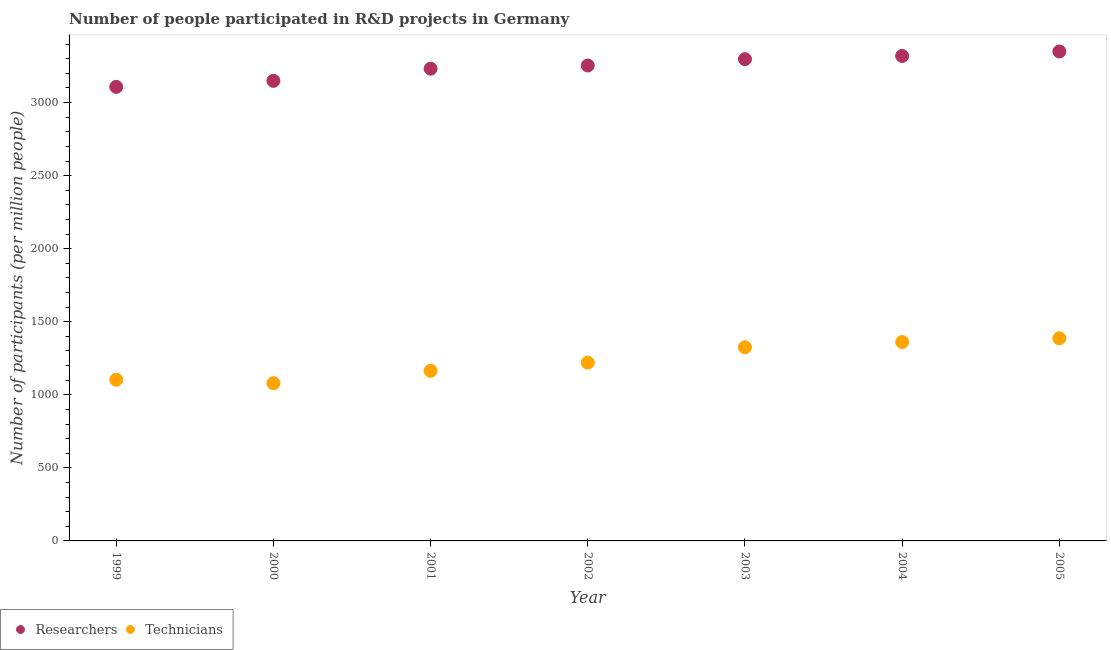Is the number of dotlines equal to the number of legend labels?
Keep it short and to the point. Yes. What is the number of researchers in 1999?
Make the answer very short. 3107.28. Across all years, what is the maximum number of researchers?
Give a very brief answer. 3349.65. Across all years, what is the minimum number of researchers?
Your answer should be very brief. 3107.28. In which year was the number of researchers minimum?
Keep it short and to the point. 1999. What is the total number of researchers in the graph?
Keep it short and to the point. 2.27e+04. What is the difference between the number of technicians in 2000 and that in 2001?
Your response must be concise. -84.8. What is the difference between the number of researchers in 2001 and the number of technicians in 2002?
Give a very brief answer. 2011.3. What is the average number of technicians per year?
Keep it short and to the point. 1234.21. In the year 2003, what is the difference between the number of technicians and number of researchers?
Offer a very short reply. -1971.87. What is the ratio of the number of researchers in 2002 to that in 2005?
Provide a succinct answer. 0.97. Is the number of technicians in 1999 less than that in 2000?
Your response must be concise. No. What is the difference between the highest and the second highest number of researchers?
Offer a terse response. 30.78. What is the difference between the highest and the lowest number of researchers?
Provide a succinct answer. 242.36. In how many years, is the number of researchers greater than the average number of researchers taken over all years?
Provide a short and direct response. 4. Does the number of technicians monotonically increase over the years?
Keep it short and to the point. No. Is the number of researchers strictly greater than the number of technicians over the years?
Keep it short and to the point. Yes. How many dotlines are there?
Provide a succinct answer. 2. How many years are there in the graph?
Your response must be concise. 7. Are the values on the major ticks of Y-axis written in scientific E-notation?
Offer a terse response. No. Does the graph contain any zero values?
Your answer should be very brief. No. Does the graph contain grids?
Offer a very short reply. No. How many legend labels are there?
Provide a short and direct response. 2. How are the legend labels stacked?
Keep it short and to the point. Horizontal. What is the title of the graph?
Provide a succinct answer. Number of people participated in R&D projects in Germany. Does "Researchers" appear as one of the legend labels in the graph?
Provide a short and direct response. Yes. What is the label or title of the X-axis?
Provide a succinct answer. Year. What is the label or title of the Y-axis?
Provide a succinct answer. Number of participants (per million people). What is the Number of participants (per million people) of Researchers in 1999?
Offer a terse response. 3107.28. What is the Number of participants (per million people) in Technicians in 1999?
Offer a very short reply. 1102.81. What is the Number of participants (per million people) in Researchers in 2000?
Offer a very short reply. 3148.8. What is the Number of participants (per million people) of Technicians in 2000?
Provide a short and direct response. 1079.28. What is the Number of participants (per million people) of Researchers in 2001?
Provide a short and direct response. 3231.72. What is the Number of participants (per million people) in Technicians in 2001?
Ensure brevity in your answer.  1164.08. What is the Number of participants (per million people) of Researchers in 2002?
Offer a very short reply. 3253.52. What is the Number of participants (per million people) of Technicians in 2002?
Give a very brief answer. 1220.42. What is the Number of participants (per million people) in Researchers in 2003?
Offer a very short reply. 3297.09. What is the Number of participants (per million people) of Technicians in 2003?
Provide a short and direct response. 1325.22. What is the Number of participants (per million people) of Researchers in 2004?
Keep it short and to the point. 3318.87. What is the Number of participants (per million people) of Technicians in 2004?
Give a very brief answer. 1360.92. What is the Number of participants (per million people) of Researchers in 2005?
Your answer should be very brief. 3349.65. What is the Number of participants (per million people) of Technicians in 2005?
Give a very brief answer. 1386.74. Across all years, what is the maximum Number of participants (per million people) of Researchers?
Provide a short and direct response. 3349.65. Across all years, what is the maximum Number of participants (per million people) in Technicians?
Provide a short and direct response. 1386.74. Across all years, what is the minimum Number of participants (per million people) in Researchers?
Offer a terse response. 3107.28. Across all years, what is the minimum Number of participants (per million people) in Technicians?
Ensure brevity in your answer.  1079.28. What is the total Number of participants (per million people) of Researchers in the graph?
Offer a terse response. 2.27e+04. What is the total Number of participants (per million people) of Technicians in the graph?
Provide a succinct answer. 8639.48. What is the difference between the Number of participants (per million people) in Researchers in 1999 and that in 2000?
Ensure brevity in your answer.  -41.52. What is the difference between the Number of participants (per million people) of Technicians in 1999 and that in 2000?
Offer a terse response. 23.53. What is the difference between the Number of participants (per million people) in Researchers in 1999 and that in 2001?
Offer a terse response. -124.44. What is the difference between the Number of participants (per million people) of Technicians in 1999 and that in 2001?
Make the answer very short. -61.27. What is the difference between the Number of participants (per million people) of Researchers in 1999 and that in 2002?
Provide a succinct answer. -146.24. What is the difference between the Number of participants (per million people) in Technicians in 1999 and that in 2002?
Give a very brief answer. -117.6. What is the difference between the Number of participants (per million people) of Researchers in 1999 and that in 2003?
Offer a terse response. -189.81. What is the difference between the Number of participants (per million people) in Technicians in 1999 and that in 2003?
Give a very brief answer. -222.41. What is the difference between the Number of participants (per million people) of Researchers in 1999 and that in 2004?
Keep it short and to the point. -211.59. What is the difference between the Number of participants (per million people) of Technicians in 1999 and that in 2004?
Offer a very short reply. -258.11. What is the difference between the Number of participants (per million people) in Researchers in 1999 and that in 2005?
Offer a terse response. -242.36. What is the difference between the Number of participants (per million people) of Technicians in 1999 and that in 2005?
Offer a terse response. -283.93. What is the difference between the Number of participants (per million people) of Researchers in 2000 and that in 2001?
Offer a very short reply. -82.92. What is the difference between the Number of participants (per million people) of Technicians in 2000 and that in 2001?
Give a very brief answer. -84.8. What is the difference between the Number of participants (per million people) in Researchers in 2000 and that in 2002?
Offer a very short reply. -104.72. What is the difference between the Number of participants (per million people) in Technicians in 2000 and that in 2002?
Your answer should be very brief. -141.13. What is the difference between the Number of participants (per million people) in Researchers in 2000 and that in 2003?
Offer a very short reply. -148.29. What is the difference between the Number of participants (per million people) of Technicians in 2000 and that in 2003?
Keep it short and to the point. -245.93. What is the difference between the Number of participants (per million people) of Researchers in 2000 and that in 2004?
Your answer should be very brief. -170.07. What is the difference between the Number of participants (per million people) in Technicians in 2000 and that in 2004?
Your answer should be compact. -281.64. What is the difference between the Number of participants (per million people) of Researchers in 2000 and that in 2005?
Keep it short and to the point. -200.84. What is the difference between the Number of participants (per million people) of Technicians in 2000 and that in 2005?
Make the answer very short. -307.46. What is the difference between the Number of participants (per million people) in Researchers in 2001 and that in 2002?
Offer a terse response. -21.8. What is the difference between the Number of participants (per million people) in Technicians in 2001 and that in 2002?
Make the answer very short. -56.33. What is the difference between the Number of participants (per million people) in Researchers in 2001 and that in 2003?
Offer a very short reply. -65.37. What is the difference between the Number of participants (per million people) of Technicians in 2001 and that in 2003?
Provide a succinct answer. -161.14. What is the difference between the Number of participants (per million people) of Researchers in 2001 and that in 2004?
Provide a short and direct response. -87.15. What is the difference between the Number of participants (per million people) in Technicians in 2001 and that in 2004?
Offer a terse response. -196.84. What is the difference between the Number of participants (per million people) of Researchers in 2001 and that in 2005?
Your answer should be very brief. -117.93. What is the difference between the Number of participants (per million people) in Technicians in 2001 and that in 2005?
Provide a succinct answer. -222.66. What is the difference between the Number of participants (per million people) in Researchers in 2002 and that in 2003?
Your answer should be compact. -43.57. What is the difference between the Number of participants (per million people) in Technicians in 2002 and that in 2003?
Give a very brief answer. -104.8. What is the difference between the Number of participants (per million people) of Researchers in 2002 and that in 2004?
Ensure brevity in your answer.  -65.35. What is the difference between the Number of participants (per million people) of Technicians in 2002 and that in 2004?
Provide a short and direct response. -140.5. What is the difference between the Number of participants (per million people) in Researchers in 2002 and that in 2005?
Make the answer very short. -96.13. What is the difference between the Number of participants (per million people) of Technicians in 2002 and that in 2005?
Ensure brevity in your answer.  -166.33. What is the difference between the Number of participants (per million people) in Researchers in 2003 and that in 2004?
Provide a short and direct response. -21.78. What is the difference between the Number of participants (per million people) in Technicians in 2003 and that in 2004?
Ensure brevity in your answer.  -35.7. What is the difference between the Number of participants (per million people) in Researchers in 2003 and that in 2005?
Your response must be concise. -52.55. What is the difference between the Number of participants (per million people) of Technicians in 2003 and that in 2005?
Offer a terse response. -61.52. What is the difference between the Number of participants (per million people) of Researchers in 2004 and that in 2005?
Provide a short and direct response. -30.78. What is the difference between the Number of participants (per million people) of Technicians in 2004 and that in 2005?
Provide a short and direct response. -25.82. What is the difference between the Number of participants (per million people) in Researchers in 1999 and the Number of participants (per million people) in Technicians in 2000?
Your answer should be very brief. 2028. What is the difference between the Number of participants (per million people) in Researchers in 1999 and the Number of participants (per million people) in Technicians in 2001?
Provide a short and direct response. 1943.2. What is the difference between the Number of participants (per million people) of Researchers in 1999 and the Number of participants (per million people) of Technicians in 2002?
Your response must be concise. 1886.87. What is the difference between the Number of participants (per million people) in Researchers in 1999 and the Number of participants (per million people) in Technicians in 2003?
Keep it short and to the point. 1782.06. What is the difference between the Number of participants (per million people) in Researchers in 1999 and the Number of participants (per million people) in Technicians in 2004?
Offer a terse response. 1746.36. What is the difference between the Number of participants (per million people) in Researchers in 1999 and the Number of participants (per million people) in Technicians in 2005?
Your answer should be compact. 1720.54. What is the difference between the Number of participants (per million people) in Researchers in 2000 and the Number of participants (per million people) in Technicians in 2001?
Your answer should be very brief. 1984.72. What is the difference between the Number of participants (per million people) in Researchers in 2000 and the Number of participants (per million people) in Technicians in 2002?
Your response must be concise. 1928.38. What is the difference between the Number of participants (per million people) in Researchers in 2000 and the Number of participants (per million people) in Technicians in 2003?
Offer a very short reply. 1823.58. What is the difference between the Number of participants (per million people) of Researchers in 2000 and the Number of participants (per million people) of Technicians in 2004?
Make the answer very short. 1787.88. What is the difference between the Number of participants (per million people) of Researchers in 2000 and the Number of participants (per million people) of Technicians in 2005?
Keep it short and to the point. 1762.06. What is the difference between the Number of participants (per million people) in Researchers in 2001 and the Number of participants (per million people) in Technicians in 2002?
Provide a succinct answer. 2011.3. What is the difference between the Number of participants (per million people) of Researchers in 2001 and the Number of participants (per million people) of Technicians in 2003?
Ensure brevity in your answer.  1906.5. What is the difference between the Number of participants (per million people) in Researchers in 2001 and the Number of participants (per million people) in Technicians in 2004?
Your answer should be very brief. 1870.8. What is the difference between the Number of participants (per million people) in Researchers in 2001 and the Number of participants (per million people) in Technicians in 2005?
Your response must be concise. 1844.97. What is the difference between the Number of participants (per million people) in Researchers in 2002 and the Number of participants (per million people) in Technicians in 2003?
Keep it short and to the point. 1928.3. What is the difference between the Number of participants (per million people) in Researchers in 2002 and the Number of participants (per million people) in Technicians in 2004?
Make the answer very short. 1892.6. What is the difference between the Number of participants (per million people) in Researchers in 2002 and the Number of participants (per million people) in Technicians in 2005?
Your response must be concise. 1866.78. What is the difference between the Number of participants (per million people) of Researchers in 2003 and the Number of participants (per million people) of Technicians in 2004?
Provide a succinct answer. 1936.17. What is the difference between the Number of participants (per million people) in Researchers in 2003 and the Number of participants (per million people) in Technicians in 2005?
Your response must be concise. 1910.35. What is the difference between the Number of participants (per million people) of Researchers in 2004 and the Number of participants (per million people) of Technicians in 2005?
Keep it short and to the point. 1932.13. What is the average Number of participants (per million people) of Researchers per year?
Make the answer very short. 3243.85. What is the average Number of participants (per million people) in Technicians per year?
Make the answer very short. 1234.21. In the year 1999, what is the difference between the Number of participants (per million people) of Researchers and Number of participants (per million people) of Technicians?
Provide a short and direct response. 2004.47. In the year 2000, what is the difference between the Number of participants (per million people) of Researchers and Number of participants (per million people) of Technicians?
Your response must be concise. 2069.52. In the year 2001, what is the difference between the Number of participants (per million people) of Researchers and Number of participants (per million people) of Technicians?
Your answer should be very brief. 2067.63. In the year 2002, what is the difference between the Number of participants (per million people) in Researchers and Number of participants (per million people) in Technicians?
Your answer should be very brief. 2033.1. In the year 2003, what is the difference between the Number of participants (per million people) of Researchers and Number of participants (per million people) of Technicians?
Offer a terse response. 1971.87. In the year 2004, what is the difference between the Number of participants (per million people) of Researchers and Number of participants (per million people) of Technicians?
Make the answer very short. 1957.95. In the year 2005, what is the difference between the Number of participants (per million people) of Researchers and Number of participants (per million people) of Technicians?
Ensure brevity in your answer.  1962.9. What is the ratio of the Number of participants (per million people) of Researchers in 1999 to that in 2000?
Make the answer very short. 0.99. What is the ratio of the Number of participants (per million people) in Technicians in 1999 to that in 2000?
Your answer should be very brief. 1.02. What is the ratio of the Number of participants (per million people) in Researchers in 1999 to that in 2001?
Offer a very short reply. 0.96. What is the ratio of the Number of participants (per million people) of Technicians in 1999 to that in 2001?
Your answer should be very brief. 0.95. What is the ratio of the Number of participants (per million people) of Researchers in 1999 to that in 2002?
Your answer should be very brief. 0.96. What is the ratio of the Number of participants (per million people) in Technicians in 1999 to that in 2002?
Offer a very short reply. 0.9. What is the ratio of the Number of participants (per million people) in Researchers in 1999 to that in 2003?
Your answer should be very brief. 0.94. What is the ratio of the Number of participants (per million people) of Technicians in 1999 to that in 2003?
Provide a short and direct response. 0.83. What is the ratio of the Number of participants (per million people) of Researchers in 1999 to that in 2004?
Offer a terse response. 0.94. What is the ratio of the Number of participants (per million people) of Technicians in 1999 to that in 2004?
Keep it short and to the point. 0.81. What is the ratio of the Number of participants (per million people) of Researchers in 1999 to that in 2005?
Your answer should be very brief. 0.93. What is the ratio of the Number of participants (per million people) in Technicians in 1999 to that in 2005?
Your answer should be compact. 0.8. What is the ratio of the Number of participants (per million people) of Researchers in 2000 to that in 2001?
Your response must be concise. 0.97. What is the ratio of the Number of participants (per million people) in Technicians in 2000 to that in 2001?
Make the answer very short. 0.93. What is the ratio of the Number of participants (per million people) of Researchers in 2000 to that in 2002?
Your answer should be very brief. 0.97. What is the ratio of the Number of participants (per million people) in Technicians in 2000 to that in 2002?
Your answer should be compact. 0.88. What is the ratio of the Number of participants (per million people) of Researchers in 2000 to that in 2003?
Provide a succinct answer. 0.95. What is the ratio of the Number of participants (per million people) of Technicians in 2000 to that in 2003?
Make the answer very short. 0.81. What is the ratio of the Number of participants (per million people) of Researchers in 2000 to that in 2004?
Offer a terse response. 0.95. What is the ratio of the Number of participants (per million people) in Technicians in 2000 to that in 2004?
Your answer should be compact. 0.79. What is the ratio of the Number of participants (per million people) of Researchers in 2000 to that in 2005?
Your answer should be very brief. 0.94. What is the ratio of the Number of participants (per million people) of Technicians in 2000 to that in 2005?
Your response must be concise. 0.78. What is the ratio of the Number of participants (per million people) of Technicians in 2001 to that in 2002?
Provide a succinct answer. 0.95. What is the ratio of the Number of participants (per million people) of Researchers in 2001 to that in 2003?
Give a very brief answer. 0.98. What is the ratio of the Number of participants (per million people) in Technicians in 2001 to that in 2003?
Ensure brevity in your answer.  0.88. What is the ratio of the Number of participants (per million people) of Researchers in 2001 to that in 2004?
Make the answer very short. 0.97. What is the ratio of the Number of participants (per million people) of Technicians in 2001 to that in 2004?
Your answer should be compact. 0.86. What is the ratio of the Number of participants (per million people) in Researchers in 2001 to that in 2005?
Provide a succinct answer. 0.96. What is the ratio of the Number of participants (per million people) in Technicians in 2001 to that in 2005?
Ensure brevity in your answer.  0.84. What is the ratio of the Number of participants (per million people) of Researchers in 2002 to that in 2003?
Keep it short and to the point. 0.99. What is the ratio of the Number of participants (per million people) of Technicians in 2002 to that in 2003?
Your response must be concise. 0.92. What is the ratio of the Number of participants (per million people) of Researchers in 2002 to that in 2004?
Provide a succinct answer. 0.98. What is the ratio of the Number of participants (per million people) in Technicians in 2002 to that in 2004?
Your response must be concise. 0.9. What is the ratio of the Number of participants (per million people) in Researchers in 2002 to that in 2005?
Provide a succinct answer. 0.97. What is the ratio of the Number of participants (per million people) of Technicians in 2002 to that in 2005?
Give a very brief answer. 0.88. What is the ratio of the Number of participants (per million people) of Technicians in 2003 to that in 2004?
Your answer should be very brief. 0.97. What is the ratio of the Number of participants (per million people) in Researchers in 2003 to that in 2005?
Keep it short and to the point. 0.98. What is the ratio of the Number of participants (per million people) in Technicians in 2003 to that in 2005?
Provide a short and direct response. 0.96. What is the ratio of the Number of participants (per million people) in Technicians in 2004 to that in 2005?
Give a very brief answer. 0.98. What is the difference between the highest and the second highest Number of participants (per million people) in Researchers?
Your answer should be compact. 30.78. What is the difference between the highest and the second highest Number of participants (per million people) of Technicians?
Your response must be concise. 25.82. What is the difference between the highest and the lowest Number of participants (per million people) of Researchers?
Keep it short and to the point. 242.36. What is the difference between the highest and the lowest Number of participants (per million people) of Technicians?
Offer a very short reply. 307.46. 